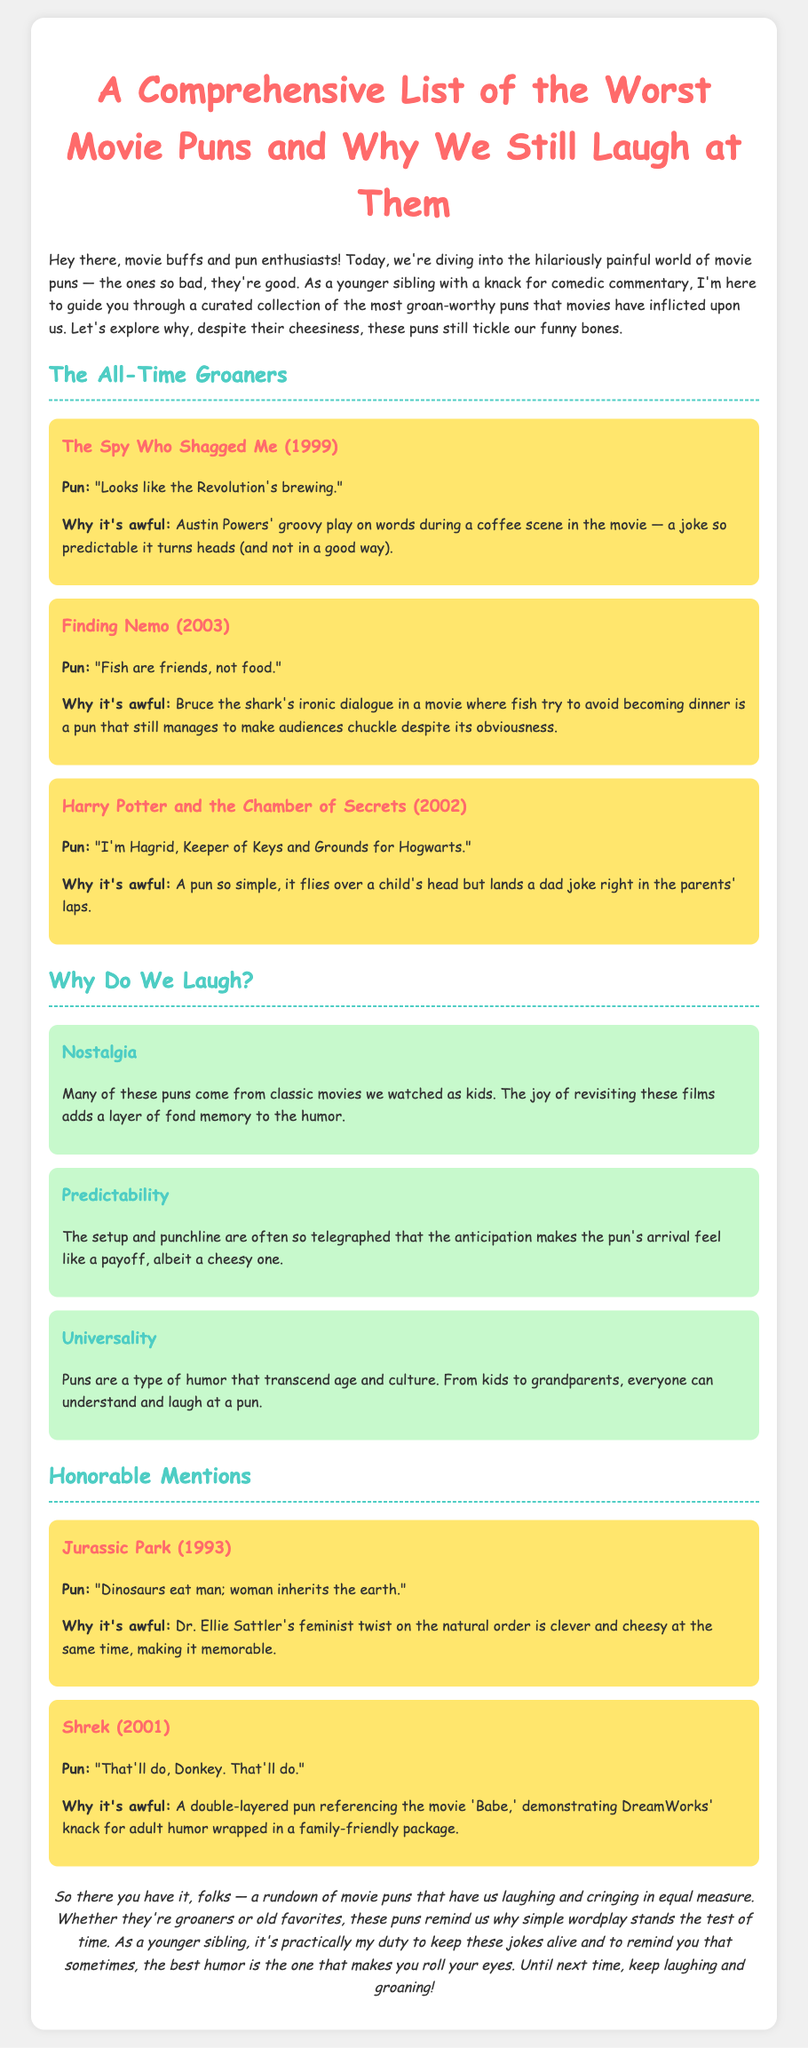what is the title of the document? The title is mentioned in the header of the document.
Answer: A Comprehensive List of the Worst Movie Puns and Why We Still Laugh at Them who directed "The Spy Who Shagged Me"? The document lists the movie along with its release year but does not specify the director.
Answer: Not specified what year was "Finding Nemo" released? The release year is provided in the pun box for "Finding Nemo."
Answer: 2003 name a reason why we laugh at movie puns. The document lists multiple reasons under the "Why Do We Laugh?" section.
Answer: Nostalgia how many movie puns are included in the "Honorable Mentions" section? The document contains two puns listed under the "Honorable Mentions" heading.
Answer: 2 what is the pun from "Jurassic Park"? The pun is listed within the pun box for "Jurassic Park."
Answer: "Dinosaurs eat man; woman inherits the earth." who is the character that says "Fish are friends, not food"? The document attributes this line to a character within "Finding Nemo."
Answer: Bruce what is the overall tone of the document? The document maintains a humorous tone throughout the critique of movie puns.
Answer: Humorous 